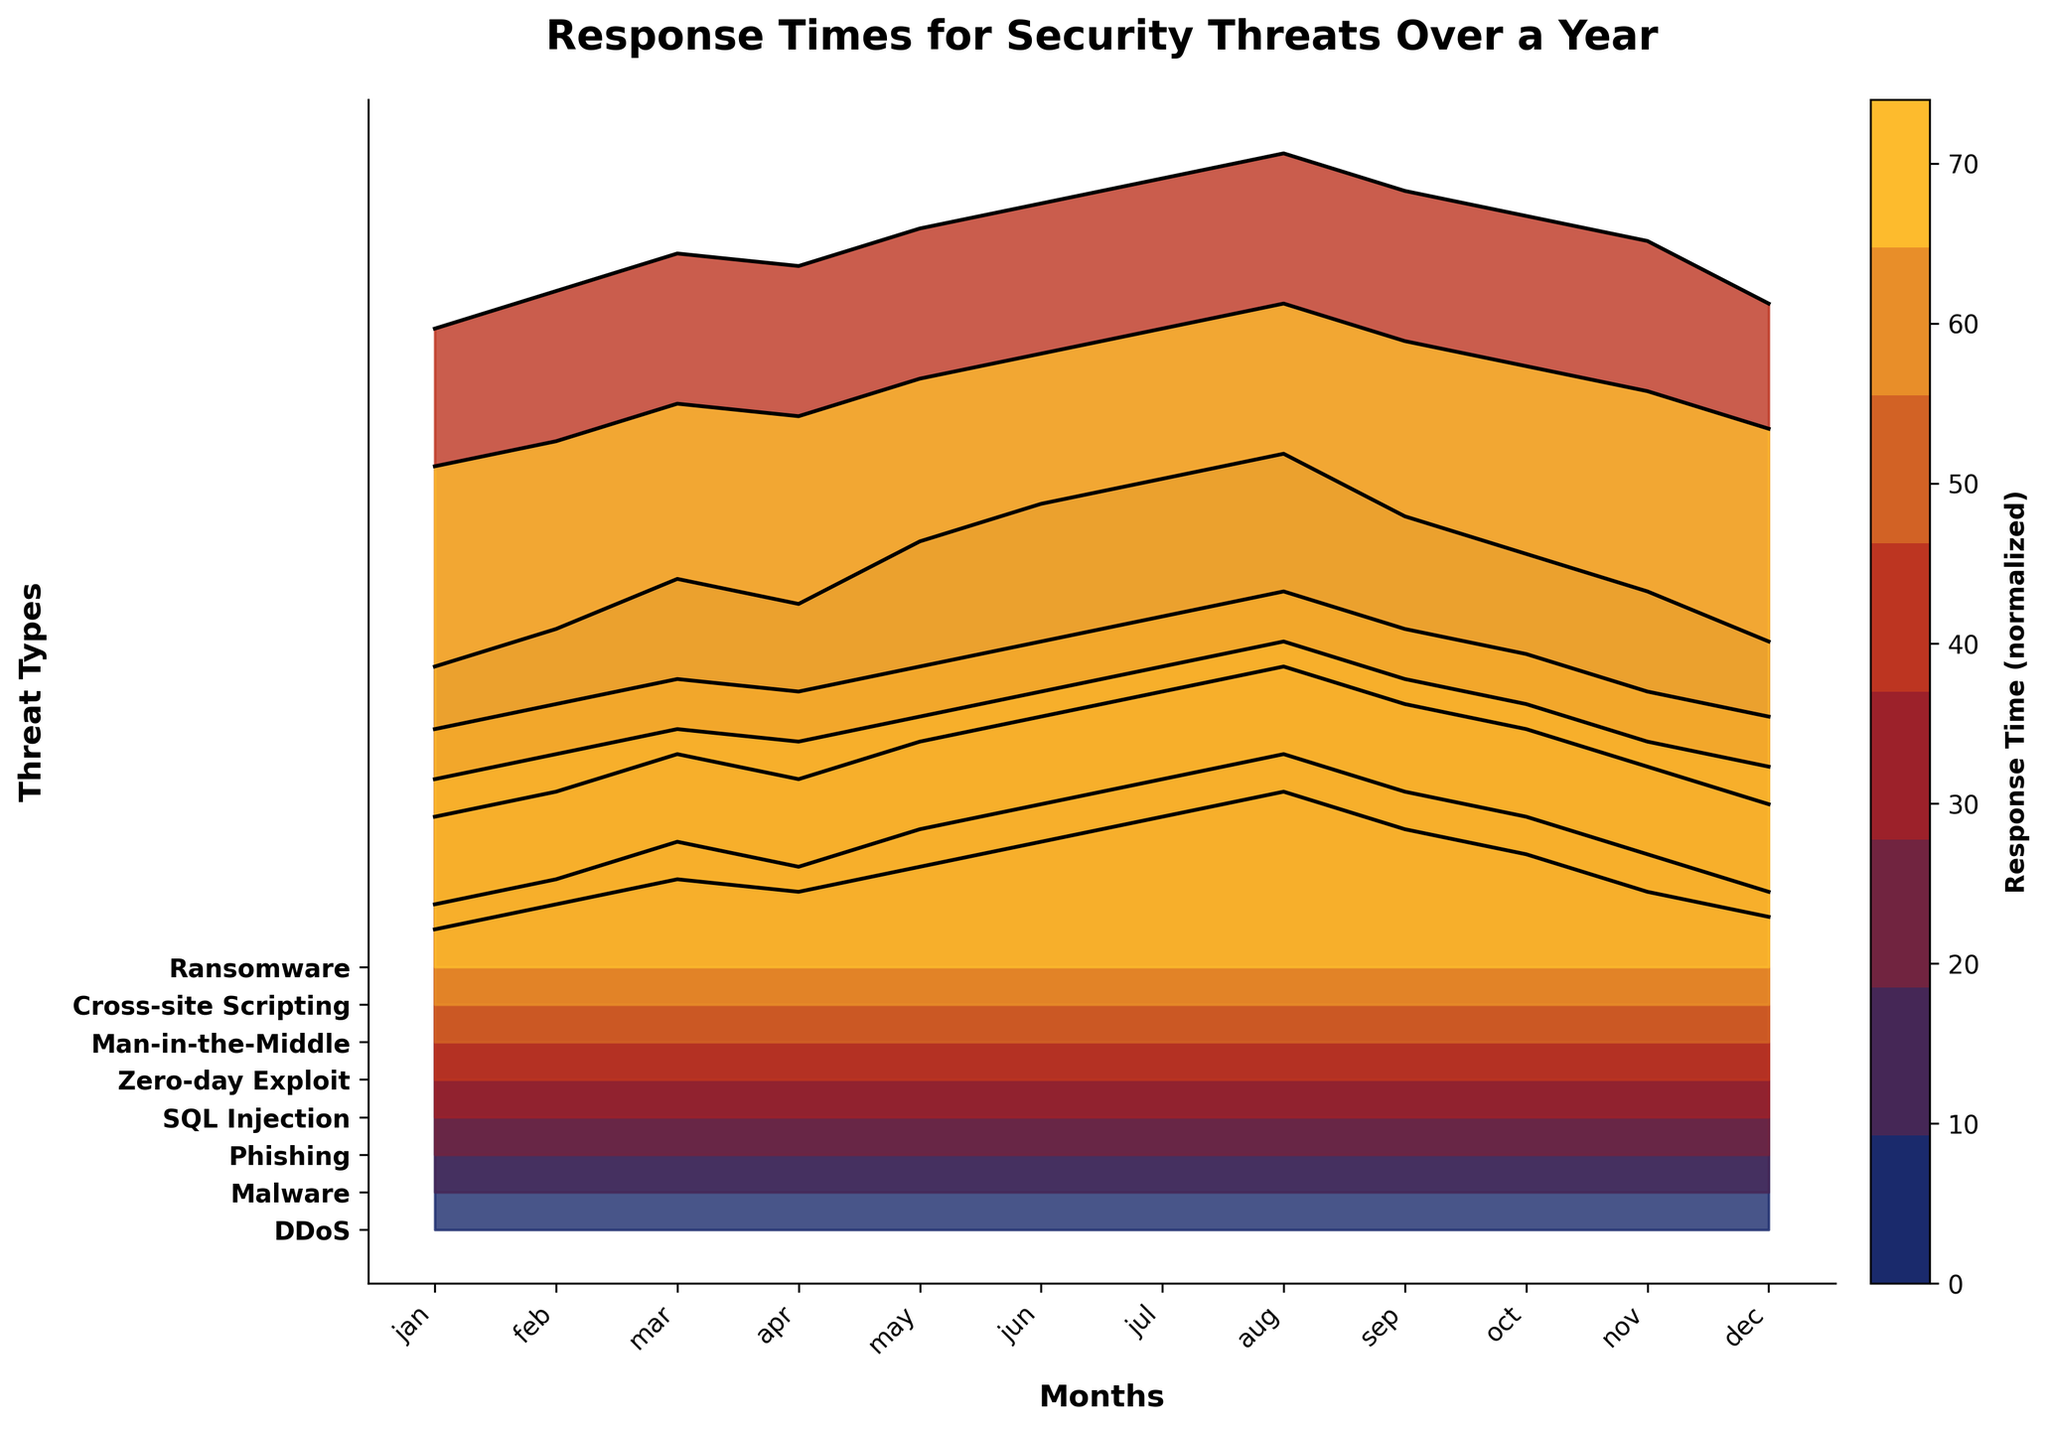What is the title of the figure? The title of the figure is typically displayed at the top of the plot. In this case, it is "Response Times for Security Threats Over a Year".
Answer: Response Times for Security Threats Over a Year Which month shows the highest response time for Zero-day Exploit? By observing the ridgeline for Zero-day Exploit, the highest point corresponds to the month of August.
Answer: August Which threat type has the lowest response time in January? Among all the plotted threat types, the lowest response time in January can be found in "SQL Injection".
Answer: SQL Injection What is the overall trend of response times for Ransomware across the months? The plot shows that the response times for Ransomware are generally increasing from January to December. Starting from 40 in January and moving up to 53 by August before slightly decreasing to 43 in December.
Answer: Increasing until August, then slightly decreasing Compare the response time for DDoS in June with Malware in December. Which one is higher? To determine this, we look at the data points on the plot for DDoS in June (58) and Malware in December (31). The response time for DDoS in June is higher.
Answer: DDoS in June How does the median response time of Phishing compare to Cross-site Scripting over the year? The response times for Phishing range from 20 to 32, and for Cross-site Scripting from 18 to 29. Calculating the median, Phishing has a median of 24.5 and Cross-site Scripting has a median of 22. Therefore, Phishing's median response time is higher.
Answer: Phishing's median is higher Which threat type shows the most variability in response times over the year? The ridgeline pattern reveals variability. Zero-day Exploit, ranging from 60 to 74 (a span of 14), shows the most notable spread compared to others.
Answer: Zero-day Exploit What is the average response time for SQL Injection in the first half of the year (January to June)? Summing the response times for SQL Injection from January to June (15 + 17 + 19 + 18 + 20 + 22 = 111) and dividing by 6 gives an average of 18.5.
Answer: 18.5 Which two months have the closest response times for Man-in-the-Middle? Observing the ridgeline, the response times for Man-in-the-Middle in May (30) and November (28) are close, with only a 2-unit difference.
Answer: May and November 